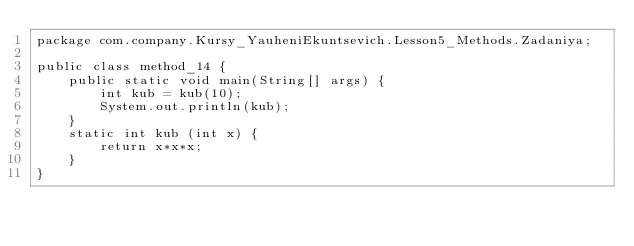Convert code to text. <code><loc_0><loc_0><loc_500><loc_500><_Java_>package com.company.Kursy_YauheniEkuntsevich.Lesson5_Methods.Zadaniya;

public class method_14 {
    public static void main(String[] args) {
        int kub = kub(10);
        System.out.println(kub);
    }
    static int kub (int x) {
        return x*x*x;
    }
}
</code> 